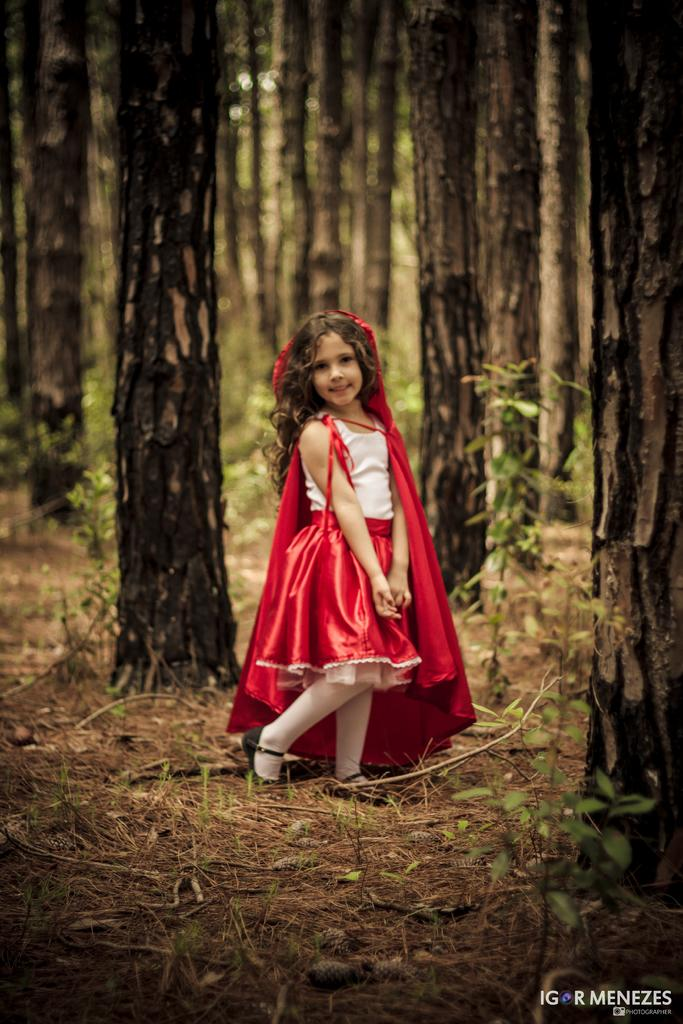Who is the main subject in the image? There is a small girl in the center of the image. What is the girl wearing? The girl is wearing a red color frock. What can be seen in the background of the image? There are trees in the background of the image. Can you see any visible veins on the girl's hands in the image? There is no information about the girl's hands or veins in the image, so it cannot be determined. 